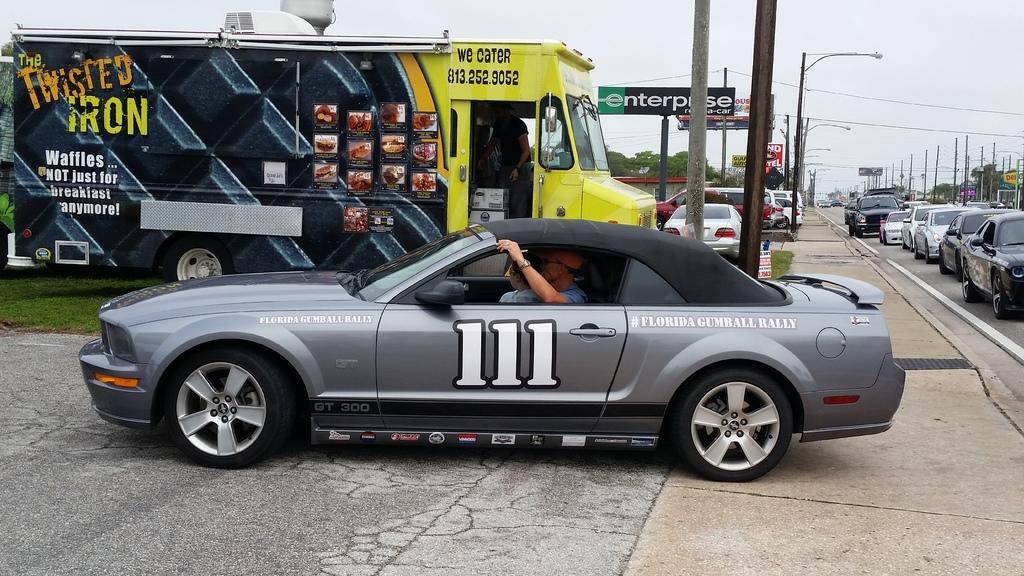How would you summarize this image in a sentence or two? As we can see in the image there is a truck, banner, cars, street lamps, trees and sky. 